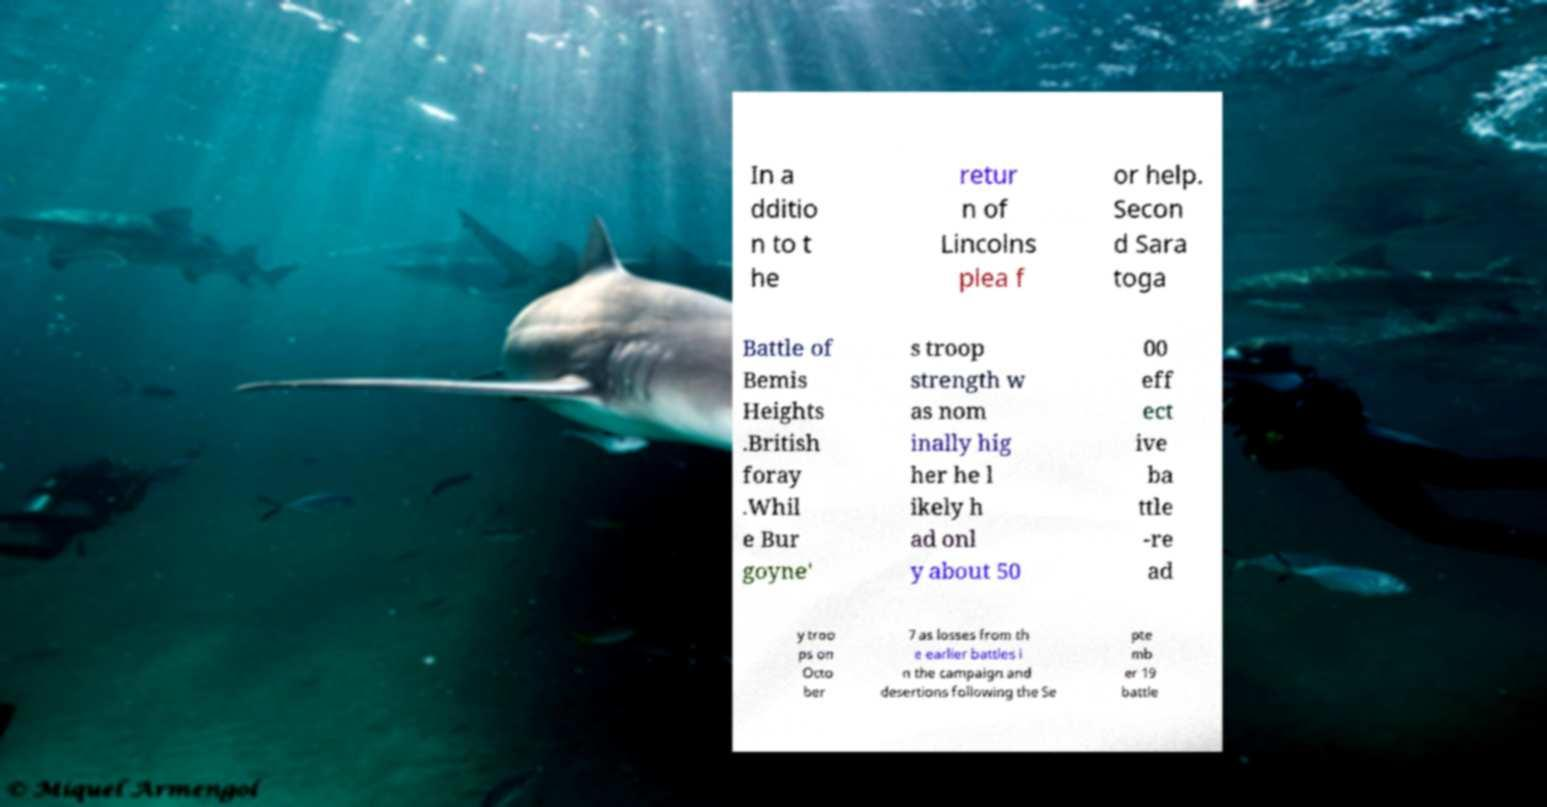Please identify and transcribe the text found in this image. In a dditio n to t he retur n of Lincolns plea f or help. Secon d Sara toga Battle of Bemis Heights .British foray .Whil e Bur goyne' s troop strength w as nom inally hig her he l ikely h ad onl y about 50 00 eff ect ive ba ttle -re ad y troo ps on Octo ber 7 as losses from th e earlier battles i n the campaign and desertions following the Se pte mb er 19 battle 